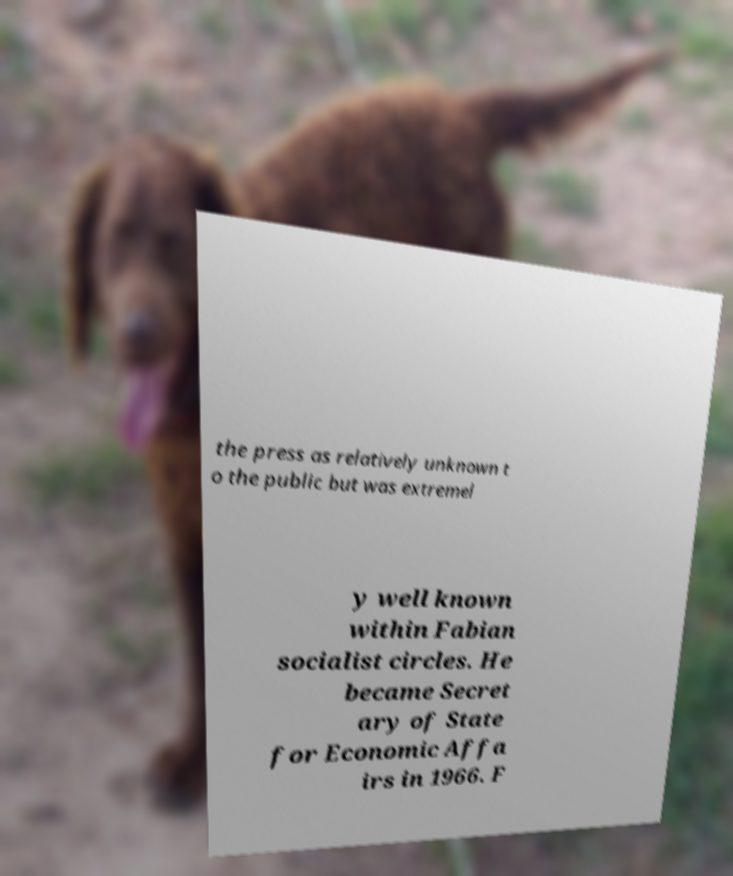Could you assist in decoding the text presented in this image and type it out clearly? the press as relatively unknown t o the public but was extremel y well known within Fabian socialist circles. He became Secret ary of State for Economic Affa irs in 1966. F 